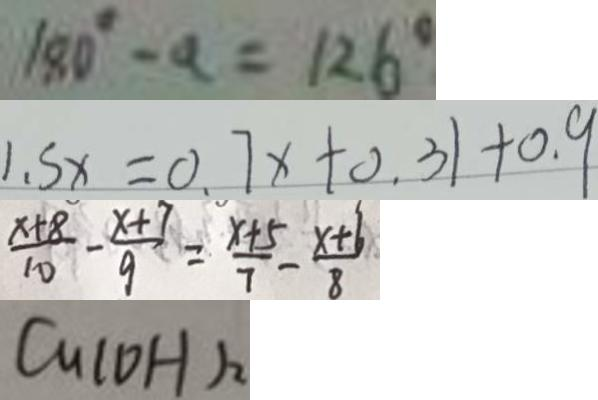Convert formula to latex. <formula><loc_0><loc_0><loc_500><loc_500>1 8 0 ^ { \circ } - a = 1 2 6 ^ { \circ } 
 1 . 5 x = 0 . 7 x + 0 . 3 1 + 0 . 9 
 \frac { x + 8 } { 1 0 } - \frac { x + 7 } { 9 } = \frac { x + 5 } { 7 } - \frac { x + 6 } { 8 } 
 C u ( O H ) _ { 2 }</formula> 